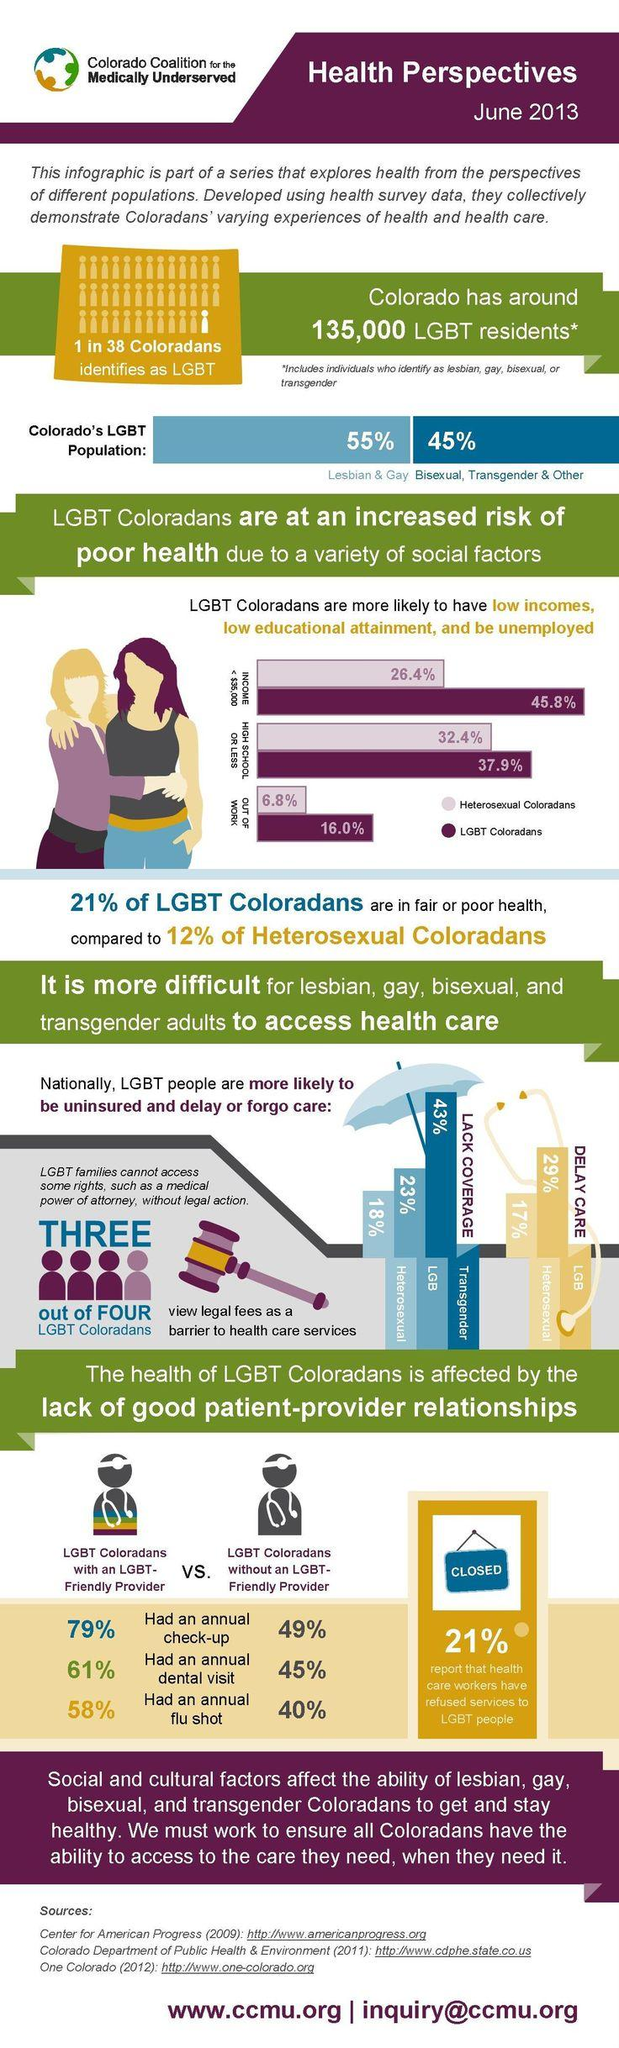Point out several critical features in this image. The percentage of LGBT individuals who received a flu shot increased by 18% when they had an LGBT-friendly provider. The percentage difference between LGBT and heterosexuals in Colorado is 9%. A study found that when individuals visited a dentist with a provider who was friendly towards the LGBT community, there was a 16% increase in the number of LGBT patients. According to the data, approximately 22.8% of LGBT Coloradans and heterosexual Coloradans are not currently employed. The percentage increase of the Lesbian & Gay population in Colorado in comparison to Bisexual, Transgender & others is 10%. 